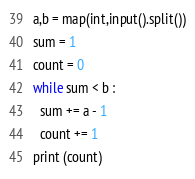Convert code to text. <code><loc_0><loc_0><loc_500><loc_500><_Python_>a,b = map(int,input().split())
sum = 1
count = 0
while sum < b :
  sum += a - 1
  count += 1
print (count)</code> 